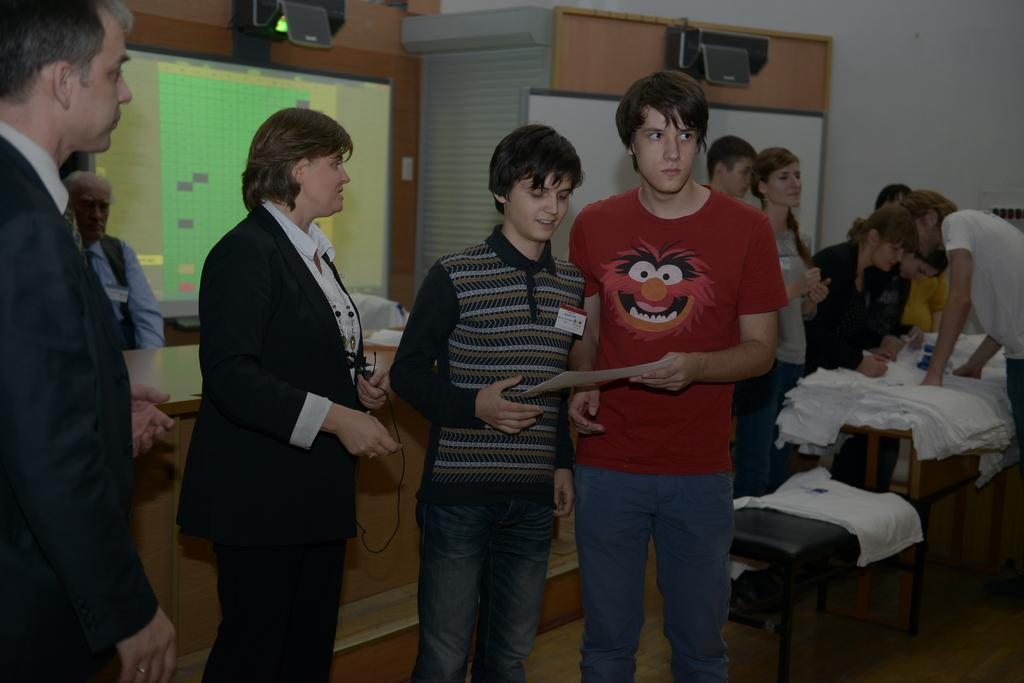What are the people in the image doing? The people in the image are standing on the floor. Can you describe the scene in the background? There are people standing around a table in the background. What is on the table in the background? There are many t-shirts on the table. Are there any mice running around on the table with the t-shirts? There is no mention of mice in the image, so we cannot say if they are present or not. 